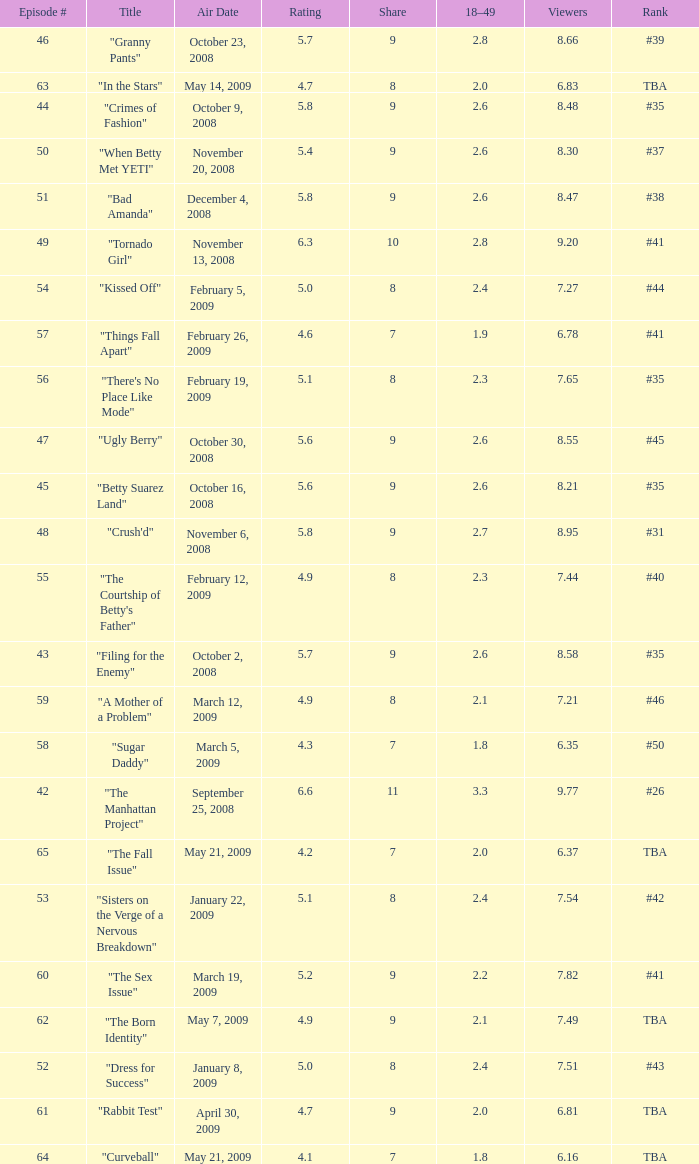What is the average Episode # with a 7 share and 18–49 is less than 2 and the Air Date of may 21, 2009? 64.0. 